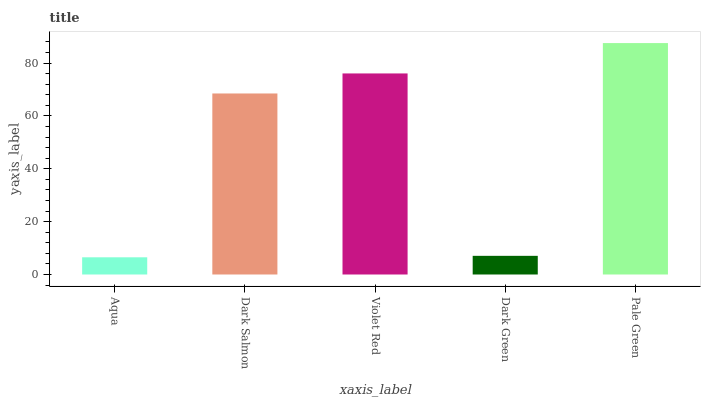Is Aqua the minimum?
Answer yes or no. Yes. Is Pale Green the maximum?
Answer yes or no. Yes. Is Dark Salmon the minimum?
Answer yes or no. No. Is Dark Salmon the maximum?
Answer yes or no. No. Is Dark Salmon greater than Aqua?
Answer yes or no. Yes. Is Aqua less than Dark Salmon?
Answer yes or no. Yes. Is Aqua greater than Dark Salmon?
Answer yes or no. No. Is Dark Salmon less than Aqua?
Answer yes or no. No. Is Dark Salmon the high median?
Answer yes or no. Yes. Is Dark Salmon the low median?
Answer yes or no. Yes. Is Pale Green the high median?
Answer yes or no. No. Is Aqua the low median?
Answer yes or no. No. 